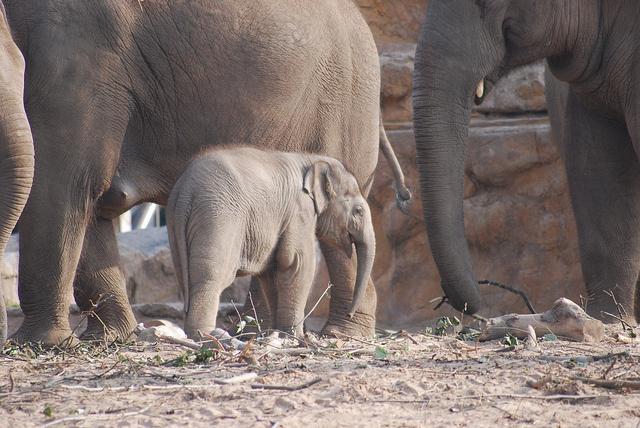Describe the objects in this image and their specific colors. I can see elephant in darkgray, gray, and black tones, elephant in darkgray, gray, and black tones, elephant in darkgray, gray, and lightgray tones, and elephant in darkgray, gray, and tan tones in this image. 